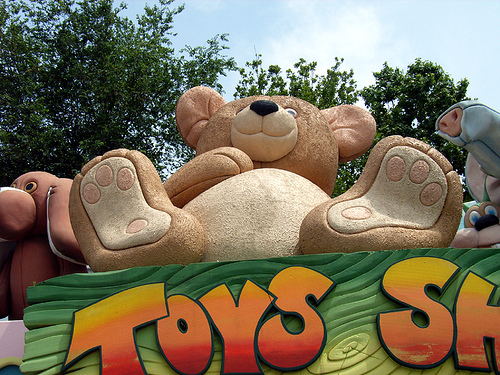Identify and read out the text in this image. TOYS SH 